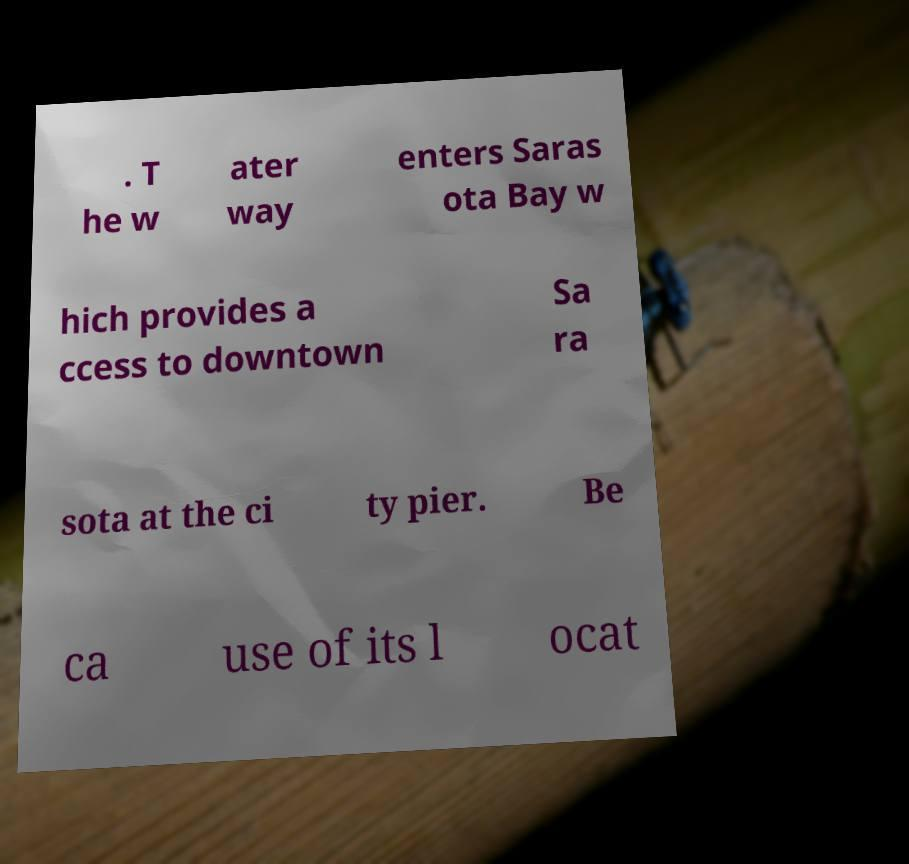I need the written content from this picture converted into text. Can you do that? . T he w ater way enters Saras ota Bay w hich provides a ccess to downtown Sa ra sota at the ci ty pier. Be ca use of its l ocat 